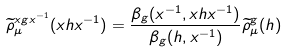<formula> <loc_0><loc_0><loc_500><loc_500>\widetilde { \rho } ^ { x g x ^ { - 1 } } _ { \mu } ( x h x ^ { - 1 } ) = \frac { \beta _ { g } ( x ^ { - 1 } , x h x ^ { - 1 } ) } { \beta _ { g } ( h , x ^ { - 1 } ) } \widetilde { \rho } ^ { g } _ { \mu } ( h )</formula> 